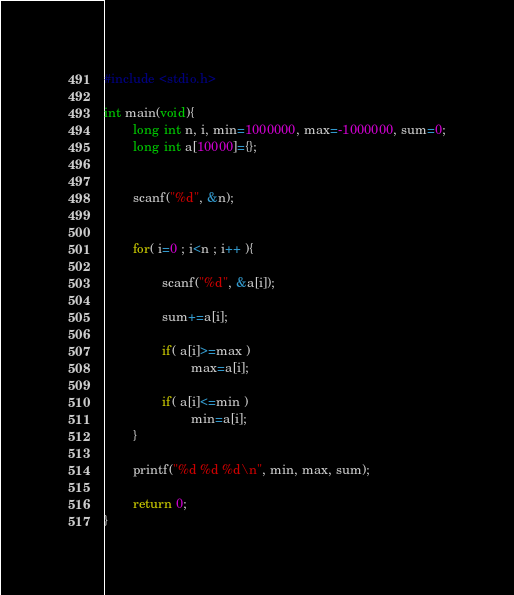Convert code to text. <code><loc_0><loc_0><loc_500><loc_500><_C_>#include <stdio.h>

int main(void){
        long int n, i, min=1000000, max=-1000000, sum=0;
        long int a[10000]={};


        scanf("%d", &n);


        for( i=0 ; i<n ; i++ ){

                scanf("%d", &a[i]);

                sum+=a[i];

                if( a[i]>=max )
                        max=a[i];

                if( a[i]<=min )
                        min=a[i];
        }

        printf("%d %d %d\n", min, max, sum);

        return 0;
}
</code> 